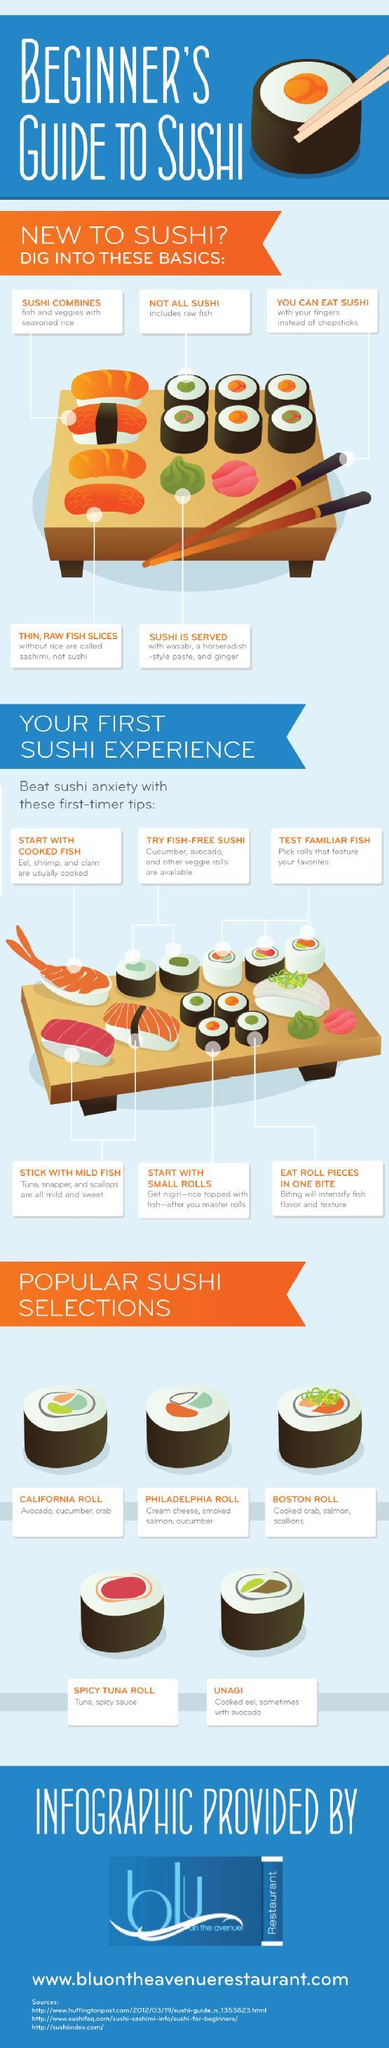Which is the second last Sushi mentioned under Popular sushi selection
Answer the question with a short phrase. Spicy Tuna Roll How many different Sushi are available? 5 What is exactly Sushi? fish and veggies with seasoned rice What are the major ingredients of California Roll? Avocado, Cucumber, Crab How many tips are mentioned for first users of Sushi? 6 